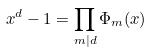Convert formula to latex. <formula><loc_0><loc_0><loc_500><loc_500>x ^ { d } - 1 = \prod _ { m | d } \Phi _ { m } ( x )</formula> 